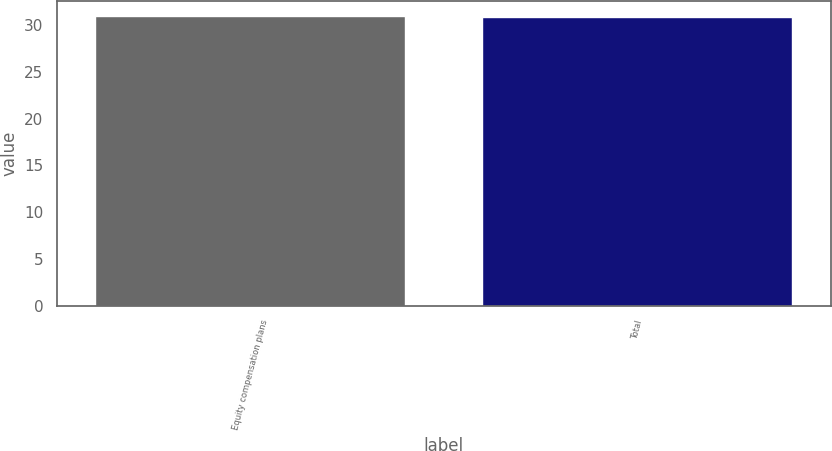Convert chart to OTSL. <chart><loc_0><loc_0><loc_500><loc_500><bar_chart><fcel>Equity compensation plans<fcel>Total<nl><fcel>31.01<fcel>30.83<nl></chart> 